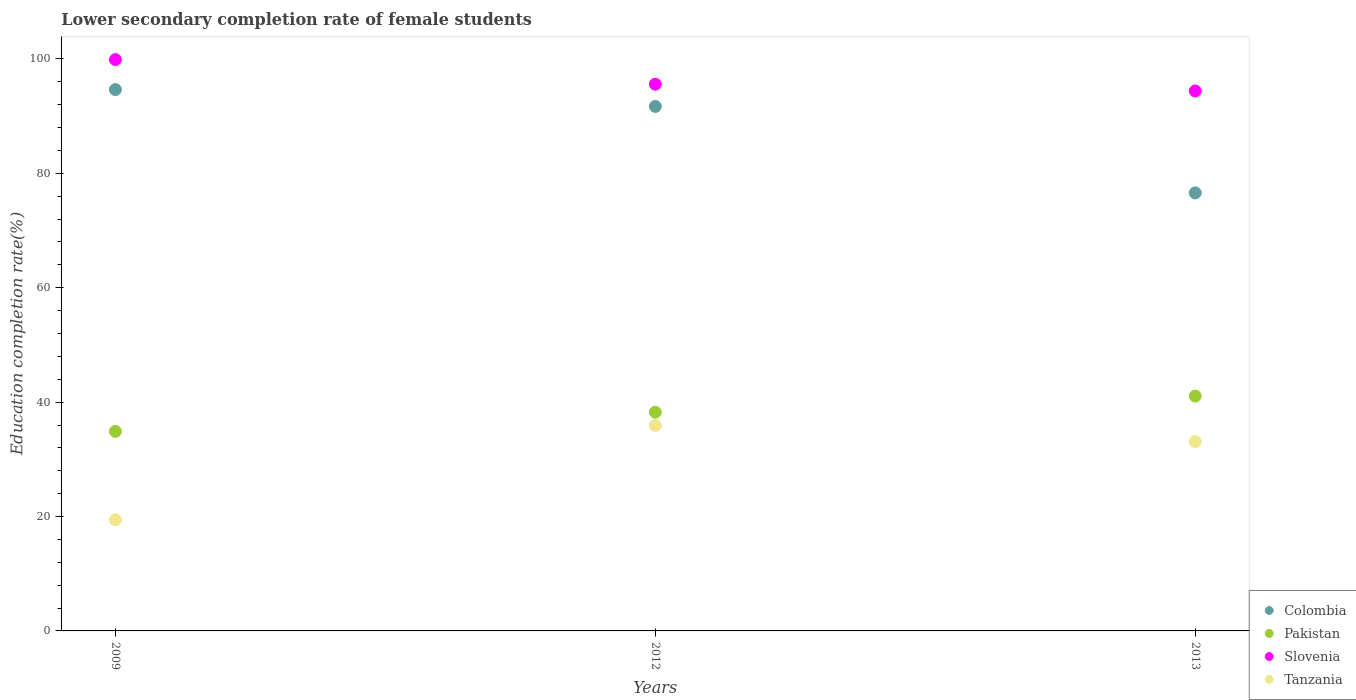Is the number of dotlines equal to the number of legend labels?
Provide a short and direct response. Yes. What is the lower secondary completion rate of female students in Tanzania in 2009?
Ensure brevity in your answer.  19.43. Across all years, what is the maximum lower secondary completion rate of female students in Pakistan?
Provide a short and direct response. 41.06. Across all years, what is the minimum lower secondary completion rate of female students in Pakistan?
Make the answer very short. 34.88. In which year was the lower secondary completion rate of female students in Slovenia minimum?
Offer a very short reply. 2013. What is the total lower secondary completion rate of female students in Tanzania in the graph?
Your answer should be very brief. 88.43. What is the difference between the lower secondary completion rate of female students in Colombia in 2009 and that in 2013?
Give a very brief answer. 18.06. What is the difference between the lower secondary completion rate of female students in Pakistan in 2013 and the lower secondary completion rate of female students in Colombia in 2009?
Offer a very short reply. -53.58. What is the average lower secondary completion rate of female students in Pakistan per year?
Provide a short and direct response. 38.06. In the year 2009, what is the difference between the lower secondary completion rate of female students in Slovenia and lower secondary completion rate of female students in Colombia?
Make the answer very short. 5.25. What is the ratio of the lower secondary completion rate of female students in Colombia in 2009 to that in 2013?
Make the answer very short. 1.24. Is the difference between the lower secondary completion rate of female students in Slovenia in 2009 and 2012 greater than the difference between the lower secondary completion rate of female students in Colombia in 2009 and 2012?
Provide a succinct answer. Yes. What is the difference between the highest and the second highest lower secondary completion rate of female students in Tanzania?
Provide a succinct answer. 2.83. What is the difference between the highest and the lowest lower secondary completion rate of female students in Colombia?
Offer a very short reply. 18.06. In how many years, is the lower secondary completion rate of female students in Pakistan greater than the average lower secondary completion rate of female students in Pakistan taken over all years?
Your response must be concise. 2. Is the sum of the lower secondary completion rate of female students in Tanzania in 2009 and 2012 greater than the maximum lower secondary completion rate of female students in Slovenia across all years?
Give a very brief answer. No. Is it the case that in every year, the sum of the lower secondary completion rate of female students in Tanzania and lower secondary completion rate of female students in Slovenia  is greater than the sum of lower secondary completion rate of female students in Colombia and lower secondary completion rate of female students in Pakistan?
Your answer should be very brief. No. Is it the case that in every year, the sum of the lower secondary completion rate of female students in Colombia and lower secondary completion rate of female students in Slovenia  is greater than the lower secondary completion rate of female students in Pakistan?
Your answer should be very brief. Yes. Is the lower secondary completion rate of female students in Tanzania strictly greater than the lower secondary completion rate of female students in Pakistan over the years?
Offer a terse response. No. How many years are there in the graph?
Make the answer very short. 3. What is the difference between two consecutive major ticks on the Y-axis?
Ensure brevity in your answer.  20. Does the graph contain grids?
Provide a succinct answer. No. Where does the legend appear in the graph?
Keep it short and to the point. Bottom right. How many legend labels are there?
Keep it short and to the point. 4. How are the legend labels stacked?
Your response must be concise. Vertical. What is the title of the graph?
Provide a succinct answer. Lower secondary completion rate of female students. Does "OECD members" appear as one of the legend labels in the graph?
Make the answer very short. No. What is the label or title of the X-axis?
Give a very brief answer. Years. What is the label or title of the Y-axis?
Your answer should be compact. Education completion rate(%). What is the Education completion rate(%) in Colombia in 2009?
Your answer should be very brief. 94.64. What is the Education completion rate(%) of Pakistan in 2009?
Your answer should be very brief. 34.88. What is the Education completion rate(%) in Slovenia in 2009?
Provide a short and direct response. 99.89. What is the Education completion rate(%) of Tanzania in 2009?
Offer a very short reply. 19.43. What is the Education completion rate(%) of Colombia in 2012?
Provide a succinct answer. 91.7. What is the Education completion rate(%) in Pakistan in 2012?
Make the answer very short. 38.24. What is the Education completion rate(%) of Slovenia in 2012?
Your answer should be very brief. 95.59. What is the Education completion rate(%) in Tanzania in 2012?
Provide a short and direct response. 35.92. What is the Education completion rate(%) in Colombia in 2013?
Provide a succinct answer. 76.58. What is the Education completion rate(%) of Pakistan in 2013?
Your response must be concise. 41.06. What is the Education completion rate(%) of Slovenia in 2013?
Keep it short and to the point. 94.4. What is the Education completion rate(%) of Tanzania in 2013?
Give a very brief answer. 33.09. Across all years, what is the maximum Education completion rate(%) in Colombia?
Offer a terse response. 94.64. Across all years, what is the maximum Education completion rate(%) of Pakistan?
Your answer should be very brief. 41.06. Across all years, what is the maximum Education completion rate(%) of Slovenia?
Make the answer very short. 99.89. Across all years, what is the maximum Education completion rate(%) of Tanzania?
Ensure brevity in your answer.  35.92. Across all years, what is the minimum Education completion rate(%) of Colombia?
Your answer should be very brief. 76.58. Across all years, what is the minimum Education completion rate(%) in Pakistan?
Your answer should be compact. 34.88. Across all years, what is the minimum Education completion rate(%) of Slovenia?
Your response must be concise. 94.4. Across all years, what is the minimum Education completion rate(%) of Tanzania?
Provide a succinct answer. 19.43. What is the total Education completion rate(%) in Colombia in the graph?
Your response must be concise. 262.91. What is the total Education completion rate(%) in Pakistan in the graph?
Keep it short and to the point. 114.19. What is the total Education completion rate(%) in Slovenia in the graph?
Ensure brevity in your answer.  289.87. What is the total Education completion rate(%) in Tanzania in the graph?
Make the answer very short. 88.43. What is the difference between the Education completion rate(%) of Colombia in 2009 and that in 2012?
Provide a short and direct response. 2.94. What is the difference between the Education completion rate(%) of Pakistan in 2009 and that in 2012?
Your answer should be compact. -3.36. What is the difference between the Education completion rate(%) in Slovenia in 2009 and that in 2012?
Your answer should be very brief. 4.3. What is the difference between the Education completion rate(%) of Tanzania in 2009 and that in 2012?
Your answer should be very brief. -16.49. What is the difference between the Education completion rate(%) in Colombia in 2009 and that in 2013?
Make the answer very short. 18.06. What is the difference between the Education completion rate(%) in Pakistan in 2009 and that in 2013?
Provide a succinct answer. -6.18. What is the difference between the Education completion rate(%) in Slovenia in 2009 and that in 2013?
Your answer should be compact. 5.48. What is the difference between the Education completion rate(%) in Tanzania in 2009 and that in 2013?
Your answer should be compact. -13.66. What is the difference between the Education completion rate(%) in Colombia in 2012 and that in 2013?
Provide a succinct answer. 15.12. What is the difference between the Education completion rate(%) in Pakistan in 2012 and that in 2013?
Offer a very short reply. -2.82. What is the difference between the Education completion rate(%) in Slovenia in 2012 and that in 2013?
Offer a terse response. 1.18. What is the difference between the Education completion rate(%) in Tanzania in 2012 and that in 2013?
Provide a succinct answer. 2.83. What is the difference between the Education completion rate(%) of Colombia in 2009 and the Education completion rate(%) of Pakistan in 2012?
Ensure brevity in your answer.  56.4. What is the difference between the Education completion rate(%) of Colombia in 2009 and the Education completion rate(%) of Slovenia in 2012?
Your answer should be very brief. -0.95. What is the difference between the Education completion rate(%) of Colombia in 2009 and the Education completion rate(%) of Tanzania in 2012?
Give a very brief answer. 58.72. What is the difference between the Education completion rate(%) of Pakistan in 2009 and the Education completion rate(%) of Slovenia in 2012?
Give a very brief answer. -60.7. What is the difference between the Education completion rate(%) of Pakistan in 2009 and the Education completion rate(%) of Tanzania in 2012?
Offer a terse response. -1.03. What is the difference between the Education completion rate(%) of Slovenia in 2009 and the Education completion rate(%) of Tanzania in 2012?
Your response must be concise. 63.97. What is the difference between the Education completion rate(%) in Colombia in 2009 and the Education completion rate(%) in Pakistan in 2013?
Your response must be concise. 53.58. What is the difference between the Education completion rate(%) in Colombia in 2009 and the Education completion rate(%) in Slovenia in 2013?
Your answer should be compact. 0.24. What is the difference between the Education completion rate(%) in Colombia in 2009 and the Education completion rate(%) in Tanzania in 2013?
Provide a succinct answer. 61.55. What is the difference between the Education completion rate(%) in Pakistan in 2009 and the Education completion rate(%) in Slovenia in 2013?
Your answer should be very brief. -59.52. What is the difference between the Education completion rate(%) in Pakistan in 2009 and the Education completion rate(%) in Tanzania in 2013?
Make the answer very short. 1.8. What is the difference between the Education completion rate(%) in Slovenia in 2009 and the Education completion rate(%) in Tanzania in 2013?
Offer a very short reply. 66.8. What is the difference between the Education completion rate(%) of Colombia in 2012 and the Education completion rate(%) of Pakistan in 2013?
Make the answer very short. 50.64. What is the difference between the Education completion rate(%) in Colombia in 2012 and the Education completion rate(%) in Slovenia in 2013?
Ensure brevity in your answer.  -2.71. What is the difference between the Education completion rate(%) in Colombia in 2012 and the Education completion rate(%) in Tanzania in 2013?
Your answer should be compact. 58.61. What is the difference between the Education completion rate(%) of Pakistan in 2012 and the Education completion rate(%) of Slovenia in 2013?
Ensure brevity in your answer.  -56.16. What is the difference between the Education completion rate(%) of Pakistan in 2012 and the Education completion rate(%) of Tanzania in 2013?
Provide a short and direct response. 5.15. What is the difference between the Education completion rate(%) in Slovenia in 2012 and the Education completion rate(%) in Tanzania in 2013?
Provide a succinct answer. 62.5. What is the average Education completion rate(%) in Colombia per year?
Make the answer very short. 87.64. What is the average Education completion rate(%) in Pakistan per year?
Your response must be concise. 38.06. What is the average Education completion rate(%) in Slovenia per year?
Offer a very short reply. 96.62. What is the average Education completion rate(%) in Tanzania per year?
Your answer should be very brief. 29.48. In the year 2009, what is the difference between the Education completion rate(%) of Colombia and Education completion rate(%) of Pakistan?
Offer a terse response. 59.76. In the year 2009, what is the difference between the Education completion rate(%) in Colombia and Education completion rate(%) in Slovenia?
Make the answer very short. -5.25. In the year 2009, what is the difference between the Education completion rate(%) of Colombia and Education completion rate(%) of Tanzania?
Give a very brief answer. 75.21. In the year 2009, what is the difference between the Education completion rate(%) of Pakistan and Education completion rate(%) of Slovenia?
Offer a terse response. -65. In the year 2009, what is the difference between the Education completion rate(%) of Pakistan and Education completion rate(%) of Tanzania?
Offer a very short reply. 15.46. In the year 2009, what is the difference between the Education completion rate(%) of Slovenia and Education completion rate(%) of Tanzania?
Keep it short and to the point. 80.46. In the year 2012, what is the difference between the Education completion rate(%) in Colombia and Education completion rate(%) in Pakistan?
Provide a short and direct response. 53.46. In the year 2012, what is the difference between the Education completion rate(%) in Colombia and Education completion rate(%) in Slovenia?
Make the answer very short. -3.89. In the year 2012, what is the difference between the Education completion rate(%) in Colombia and Education completion rate(%) in Tanzania?
Keep it short and to the point. 55.78. In the year 2012, what is the difference between the Education completion rate(%) in Pakistan and Education completion rate(%) in Slovenia?
Make the answer very short. -57.34. In the year 2012, what is the difference between the Education completion rate(%) in Pakistan and Education completion rate(%) in Tanzania?
Ensure brevity in your answer.  2.33. In the year 2012, what is the difference between the Education completion rate(%) of Slovenia and Education completion rate(%) of Tanzania?
Make the answer very short. 59.67. In the year 2013, what is the difference between the Education completion rate(%) of Colombia and Education completion rate(%) of Pakistan?
Make the answer very short. 35.52. In the year 2013, what is the difference between the Education completion rate(%) in Colombia and Education completion rate(%) in Slovenia?
Offer a terse response. -17.83. In the year 2013, what is the difference between the Education completion rate(%) in Colombia and Education completion rate(%) in Tanzania?
Provide a short and direct response. 43.49. In the year 2013, what is the difference between the Education completion rate(%) of Pakistan and Education completion rate(%) of Slovenia?
Provide a succinct answer. -53.34. In the year 2013, what is the difference between the Education completion rate(%) of Pakistan and Education completion rate(%) of Tanzania?
Give a very brief answer. 7.97. In the year 2013, what is the difference between the Education completion rate(%) in Slovenia and Education completion rate(%) in Tanzania?
Ensure brevity in your answer.  61.31. What is the ratio of the Education completion rate(%) of Colombia in 2009 to that in 2012?
Provide a succinct answer. 1.03. What is the ratio of the Education completion rate(%) of Pakistan in 2009 to that in 2012?
Your answer should be very brief. 0.91. What is the ratio of the Education completion rate(%) of Slovenia in 2009 to that in 2012?
Give a very brief answer. 1.04. What is the ratio of the Education completion rate(%) in Tanzania in 2009 to that in 2012?
Your answer should be very brief. 0.54. What is the ratio of the Education completion rate(%) of Colombia in 2009 to that in 2013?
Offer a very short reply. 1.24. What is the ratio of the Education completion rate(%) in Pakistan in 2009 to that in 2013?
Keep it short and to the point. 0.85. What is the ratio of the Education completion rate(%) in Slovenia in 2009 to that in 2013?
Give a very brief answer. 1.06. What is the ratio of the Education completion rate(%) of Tanzania in 2009 to that in 2013?
Your answer should be compact. 0.59. What is the ratio of the Education completion rate(%) of Colombia in 2012 to that in 2013?
Make the answer very short. 1.2. What is the ratio of the Education completion rate(%) in Pakistan in 2012 to that in 2013?
Ensure brevity in your answer.  0.93. What is the ratio of the Education completion rate(%) of Slovenia in 2012 to that in 2013?
Your answer should be compact. 1.01. What is the ratio of the Education completion rate(%) of Tanzania in 2012 to that in 2013?
Provide a succinct answer. 1.09. What is the difference between the highest and the second highest Education completion rate(%) of Colombia?
Keep it short and to the point. 2.94. What is the difference between the highest and the second highest Education completion rate(%) in Pakistan?
Offer a terse response. 2.82. What is the difference between the highest and the second highest Education completion rate(%) of Slovenia?
Keep it short and to the point. 4.3. What is the difference between the highest and the second highest Education completion rate(%) in Tanzania?
Ensure brevity in your answer.  2.83. What is the difference between the highest and the lowest Education completion rate(%) in Colombia?
Make the answer very short. 18.06. What is the difference between the highest and the lowest Education completion rate(%) in Pakistan?
Provide a short and direct response. 6.18. What is the difference between the highest and the lowest Education completion rate(%) in Slovenia?
Make the answer very short. 5.48. What is the difference between the highest and the lowest Education completion rate(%) of Tanzania?
Provide a succinct answer. 16.49. 